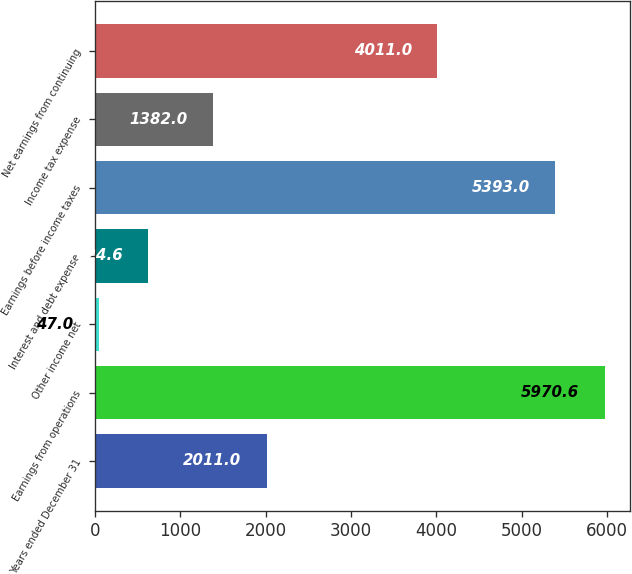Convert chart to OTSL. <chart><loc_0><loc_0><loc_500><loc_500><bar_chart><fcel>Years ended December 31<fcel>Earnings from operations<fcel>Other income net<fcel>Interest and debt expense<fcel>Earnings before income taxes<fcel>Income tax expense<fcel>Net earnings from continuing<nl><fcel>2011<fcel>5970.6<fcel>47<fcel>624.6<fcel>5393<fcel>1382<fcel>4011<nl></chart> 